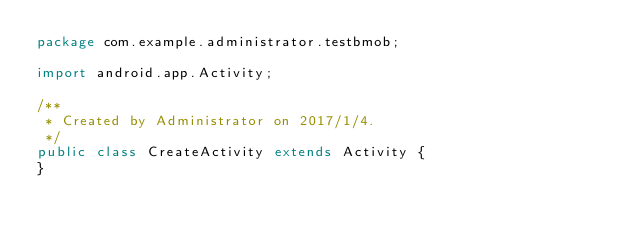Convert code to text. <code><loc_0><loc_0><loc_500><loc_500><_Java_>package com.example.administrator.testbmob;

import android.app.Activity;

/**
 * Created by Administrator on 2017/1/4.
 */
public class CreateActivity extends Activity {
}
</code> 